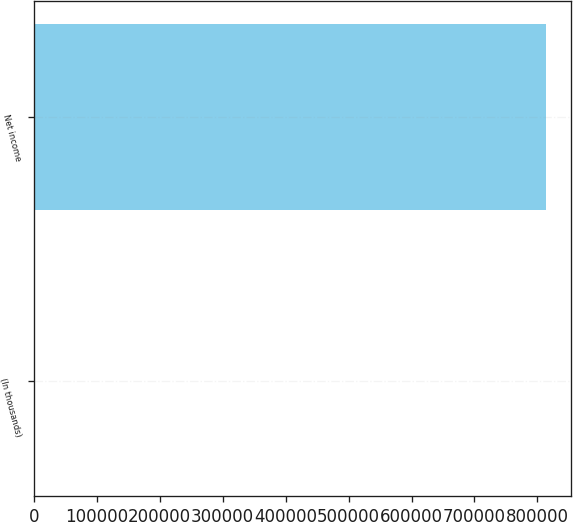Convert chart to OTSL. <chart><loc_0><loc_0><loc_500><loc_500><bar_chart><fcel>(In thousands)<fcel>Net income<nl><fcel>2015<fcel>813303<nl></chart> 